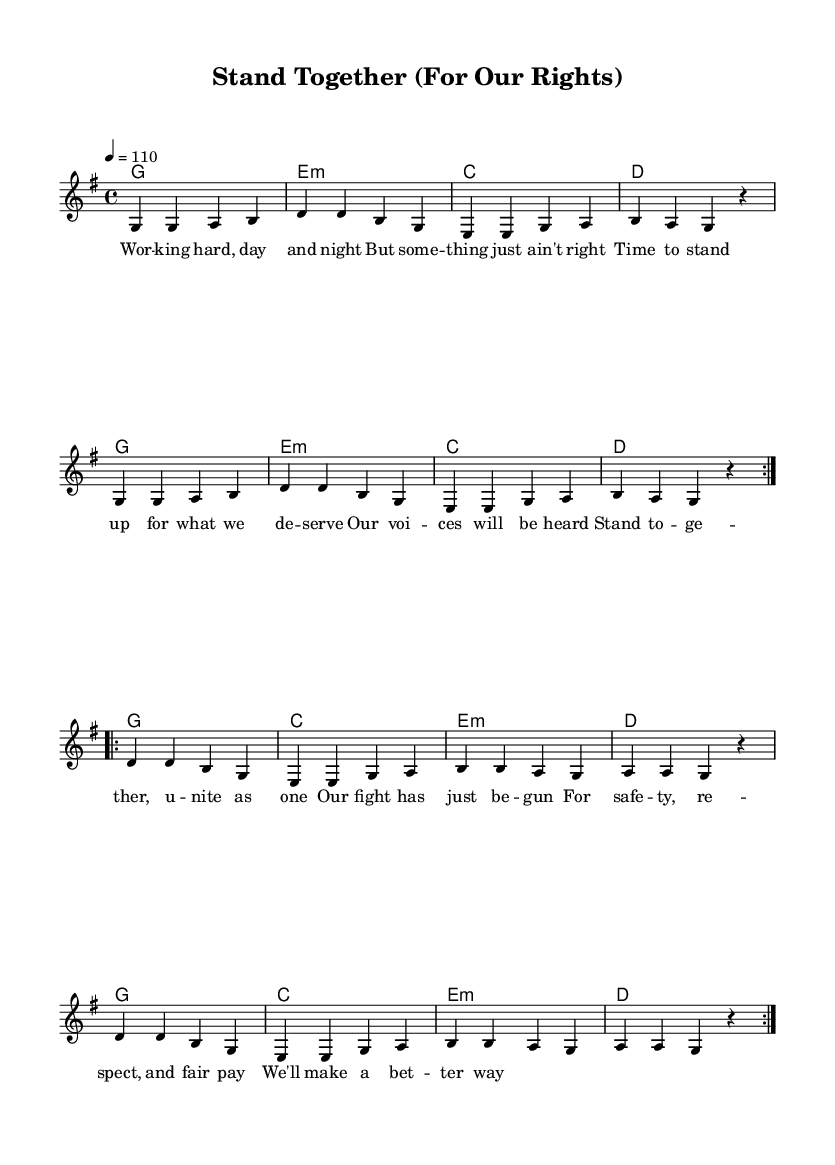What is the key signature of this music? The key signature is specified at the beginning of the score with the 'g' indicating that the piece is in G major, which has one sharp (F#).
Answer: G major What is the time signature of this music? The time signature appears at the start of the music, indicated by the numbers above the staff. The numbers 4/4 mean there are four beats per measure.
Answer: 4/4 What is the tempo marking of this music? The tempo marking shows the speed of the piece, which is indicated by the number 110. This means to play at 110 beats per minute.
Answer: 110 How many times is the first section repeated? The repeat indicators in the score show that the first section of the melody is repeated two times, as indicated by 'volta 2'.
Answer: 2 What are the main themes expressed in the lyrics? The lyrics emphasize workers standing together for their rights and seeking safety, respect, and fair pay, showcasing a theme of solidarity.
Answer: Worker solidarity What is the primary musical form of this piece? The structure of the song alternates between verses and a chorus, typical in R&B music, focusing on community and collaborative messages.
Answer: Verse-Chorus Which chord is used at the beginning of the music? The first chord listed in the harmonies section, which signifies the underlying harmony, is G, indicating the tonal center.
Answer: G 